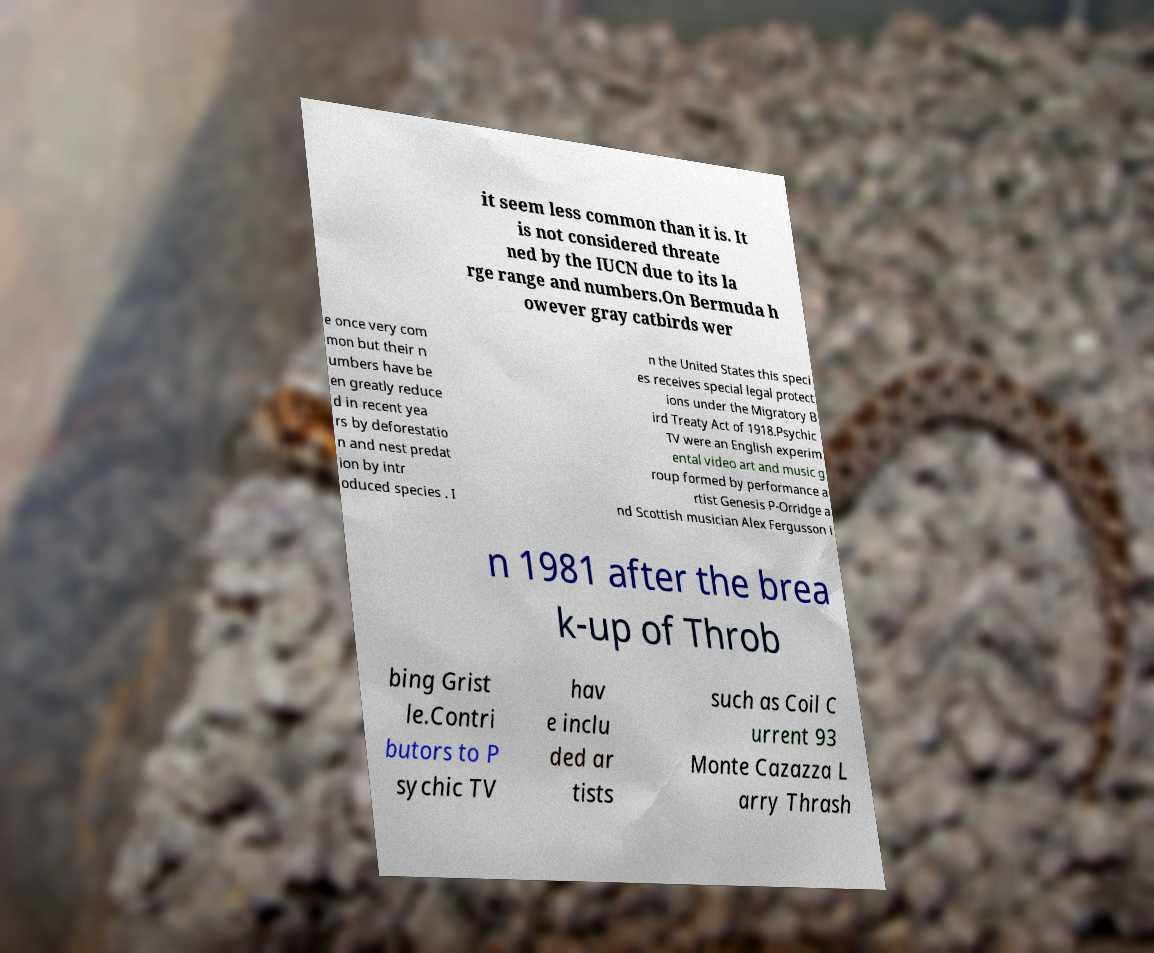Can you read and provide the text displayed in the image?This photo seems to have some interesting text. Can you extract and type it out for me? it seem less common than it is. It is not considered threate ned by the IUCN due to its la rge range and numbers.On Bermuda h owever gray catbirds wer e once very com mon but their n umbers have be en greatly reduce d in recent yea rs by deforestatio n and nest predat ion by intr oduced species . I n the United States this speci es receives special legal protect ions under the Migratory B ird Treaty Act of 1918.Psychic TV were an English experim ental video art and music g roup formed by performance a rtist Genesis P-Orridge a nd Scottish musician Alex Fergusson i n 1981 after the brea k-up of Throb bing Grist le.Contri butors to P sychic TV hav e inclu ded ar tists such as Coil C urrent 93 Monte Cazazza L arry Thrash 